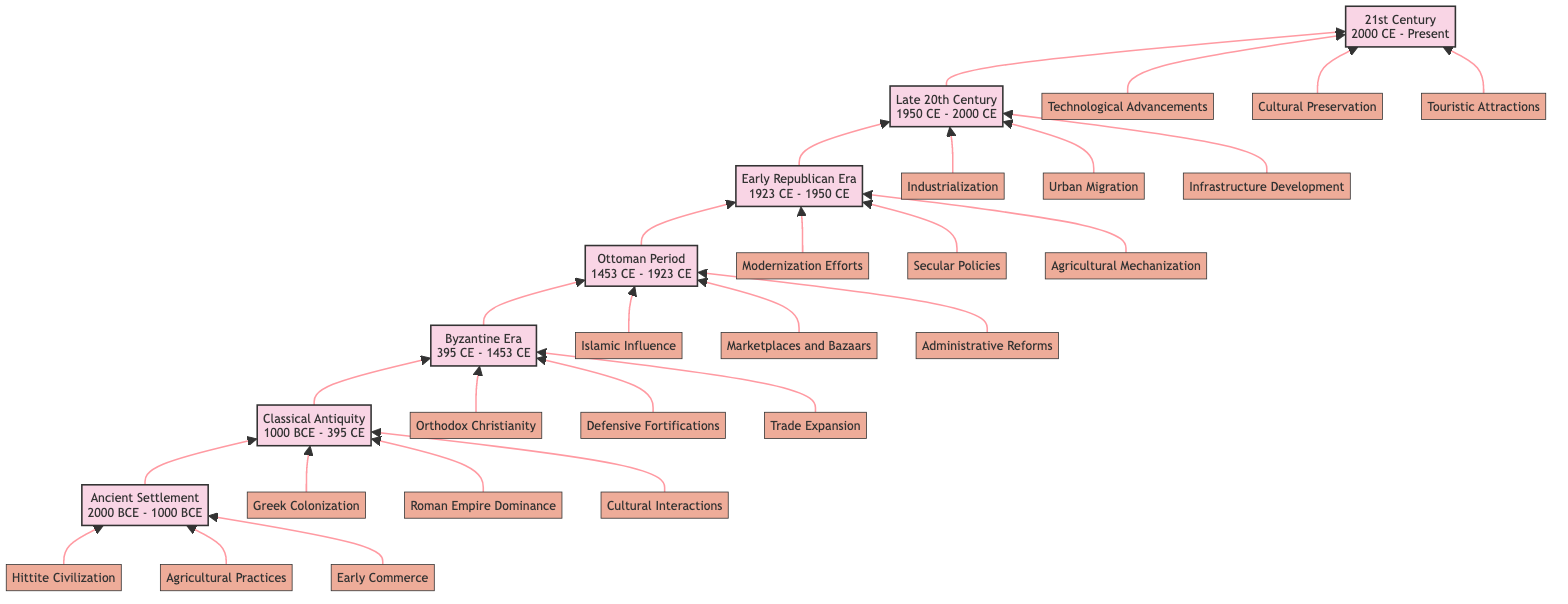What is the time period for the Ottoman Period? The diagram specifies that the Ottoman Period spans from 1453 CE to 1923 CE. This information is directly stated in the node representing the Ottoman Period.
Answer: 1453 CE - 1923 CE How many main eras are represented in the diagram? To find the total number of main eras, we can count the nodes listed from Ancient Settlement to 21st Century. There are seven distinct eras indicated in the diagram.
Answer: 7 What feature is associated with the Byzantine Era? The Byzantine Era node lists three features, one of which is "Orthodox Christianity Establishment." Selecting any one of these features provides the correct response.
Answer: Orthodox Christianity Establishment Which era comes before the Late 20th Century? The flow chart presents the eras in a bottom-to-top manner, arranging them by sequence. The node directly below the Late 20th Century is the Early Republican Era, indicating its immediate predecessor.
Answer: Early Republican Era What feature signifies the 21st Century? The 21st Century node lists "Technological Advancements" as one of its features. This feature highlights significant developments categorized under this era, and it is explicitly mentioned in the diagram.
Answer: Technological Advancements Which era followed the Byzantine Era? In the flow chart, we can trace the arrows pointing upwards. The era immediately following the Byzantine Era is the Ottoman Period, which is connected through an upward arrow.
Answer: Ottoman Period What type of market was prominent during the Ottoman Period? The Ottoman Period node highlights "Marketplaces and Bazaars" as one of its features, indicating its importance during that historical period. This information is directly available from the diagram.
Answer: Marketplaces and Bazaars What was a key development during the Early Republican Era? The features associated with the Early Republican Era include "Modernization Efforts." This feature reflects the significant changes this period aimed to achieve and is outlined in the node itself.
Answer: Modernization Efforts What cultural aspect developed in the Classical Antiquity? The Classical Antiquity era lists "Cultural Interactions" as one of its features, demonstrating the social and cultural exchanges that occurred during this time. This is explicitly mentioned within the node.
Answer: Cultural Interactions 